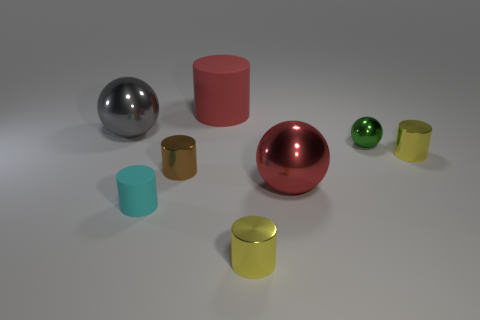Subtract all gray cylinders. Subtract all green balls. How many cylinders are left? 5 Add 1 tiny green objects. How many objects exist? 9 Subtract all cylinders. How many objects are left? 3 Subtract 0 purple blocks. How many objects are left? 8 Subtract all large brown metal cylinders. Subtract all yellow objects. How many objects are left? 6 Add 1 green metallic spheres. How many green metallic spheres are left? 2 Add 1 green objects. How many green objects exist? 2 